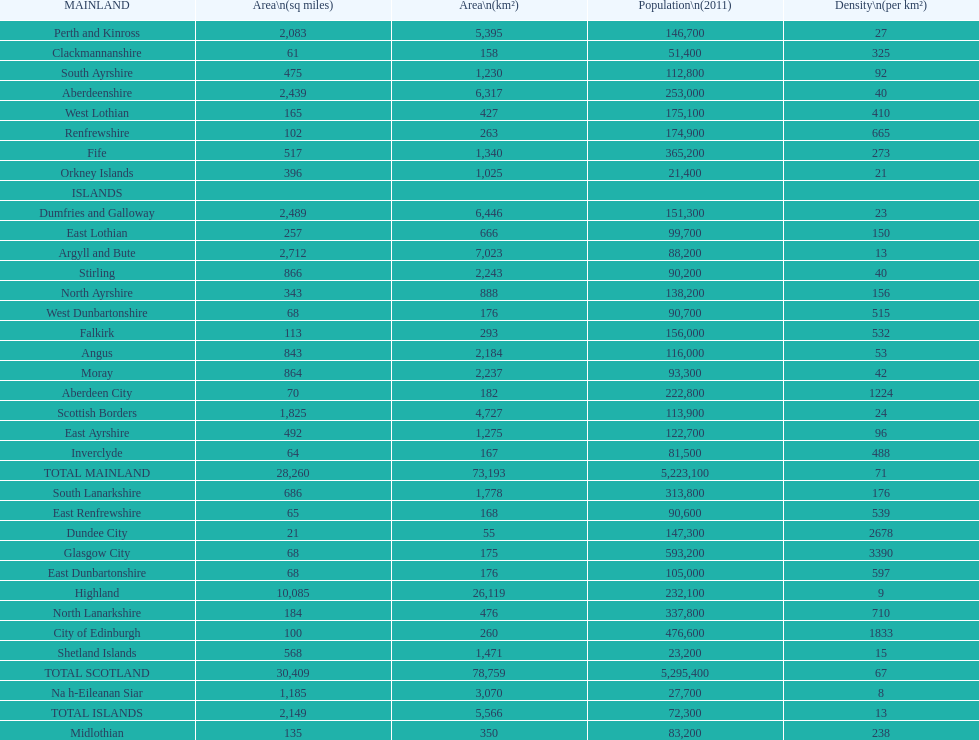What number of mainlands have populations under 100,000? 9. Could you help me parse every detail presented in this table? {'header': ['MAINLAND', 'Area\\n(sq miles)', 'Area\\n(km²)', 'Population\\n(2011)', 'Density\\n(per km²)'], 'rows': [['Perth and Kinross', '2,083', '5,395', '146,700', '27'], ['Clackmannanshire', '61', '158', '51,400', '325'], ['South Ayrshire', '475', '1,230', '112,800', '92'], ['Aberdeenshire', '2,439', '6,317', '253,000', '40'], ['West Lothian', '165', '427', '175,100', '410'], ['Renfrewshire', '102', '263', '174,900', '665'], ['Fife', '517', '1,340', '365,200', '273'], ['Orkney Islands', '396', '1,025', '21,400', '21'], ['ISLANDS', '', '', '', ''], ['Dumfries and Galloway', '2,489', '6,446', '151,300', '23'], ['East Lothian', '257', '666', '99,700', '150'], ['Argyll and Bute', '2,712', '7,023', '88,200', '13'], ['Stirling', '866', '2,243', '90,200', '40'], ['North Ayrshire', '343', '888', '138,200', '156'], ['West Dunbartonshire', '68', '176', '90,700', '515'], ['Falkirk', '113', '293', '156,000', '532'], ['Angus', '843', '2,184', '116,000', '53'], ['Moray', '864', '2,237', '93,300', '42'], ['Aberdeen City', '70', '182', '222,800', '1224'], ['Scottish Borders', '1,825', '4,727', '113,900', '24'], ['East Ayrshire', '492', '1,275', '122,700', '96'], ['Inverclyde', '64', '167', '81,500', '488'], ['TOTAL MAINLAND', '28,260', '73,193', '5,223,100', '71'], ['South Lanarkshire', '686', '1,778', '313,800', '176'], ['East Renfrewshire', '65', '168', '90,600', '539'], ['Dundee City', '21', '55', '147,300', '2678'], ['Glasgow City', '68', '175', '593,200', '3390'], ['East Dunbartonshire', '68', '176', '105,000', '597'], ['Highland', '10,085', '26,119', '232,100', '9'], ['North Lanarkshire', '184', '476', '337,800', '710'], ['City of Edinburgh', '100', '260', '476,600', '1833'], ['Shetland Islands', '568', '1,471', '23,200', '15'], ['TOTAL SCOTLAND', '30,409', '78,759', '5,295,400', '67'], ['Na h-Eileanan Siar', '1,185', '3,070', '27,700', '8'], ['TOTAL ISLANDS', '2,149', '5,566', '72,300', '13'], ['Midlothian', '135', '350', '83,200', '238']]} 